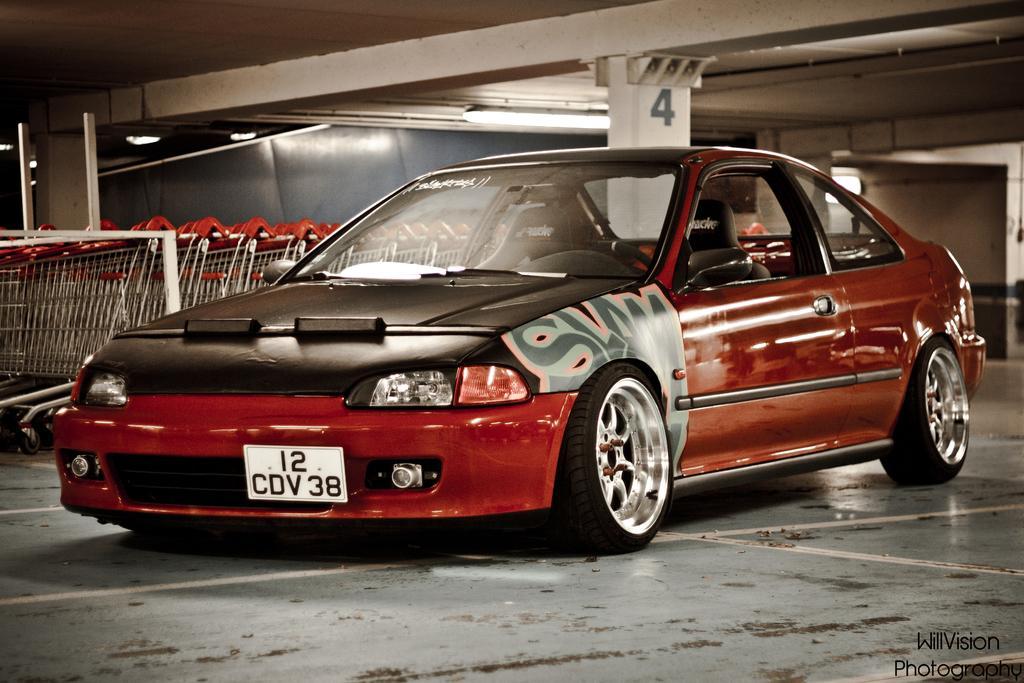In one or two sentences, can you explain what this image depicts? In this image there is a car on the ground, there are objects truncated towards the left of the image, there are pillars, there is a number on the pillar, there are lights, there is a roof truncated towards the top of the image, there is a wall truncated towards the right of the image, there is text towards the bottom of the image. 